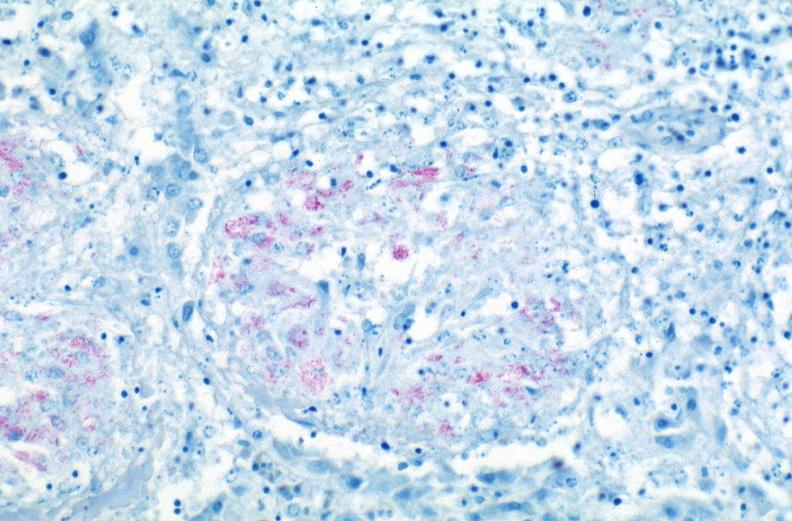s polycystic disease present?
Answer the question using a single word or phrase. No 